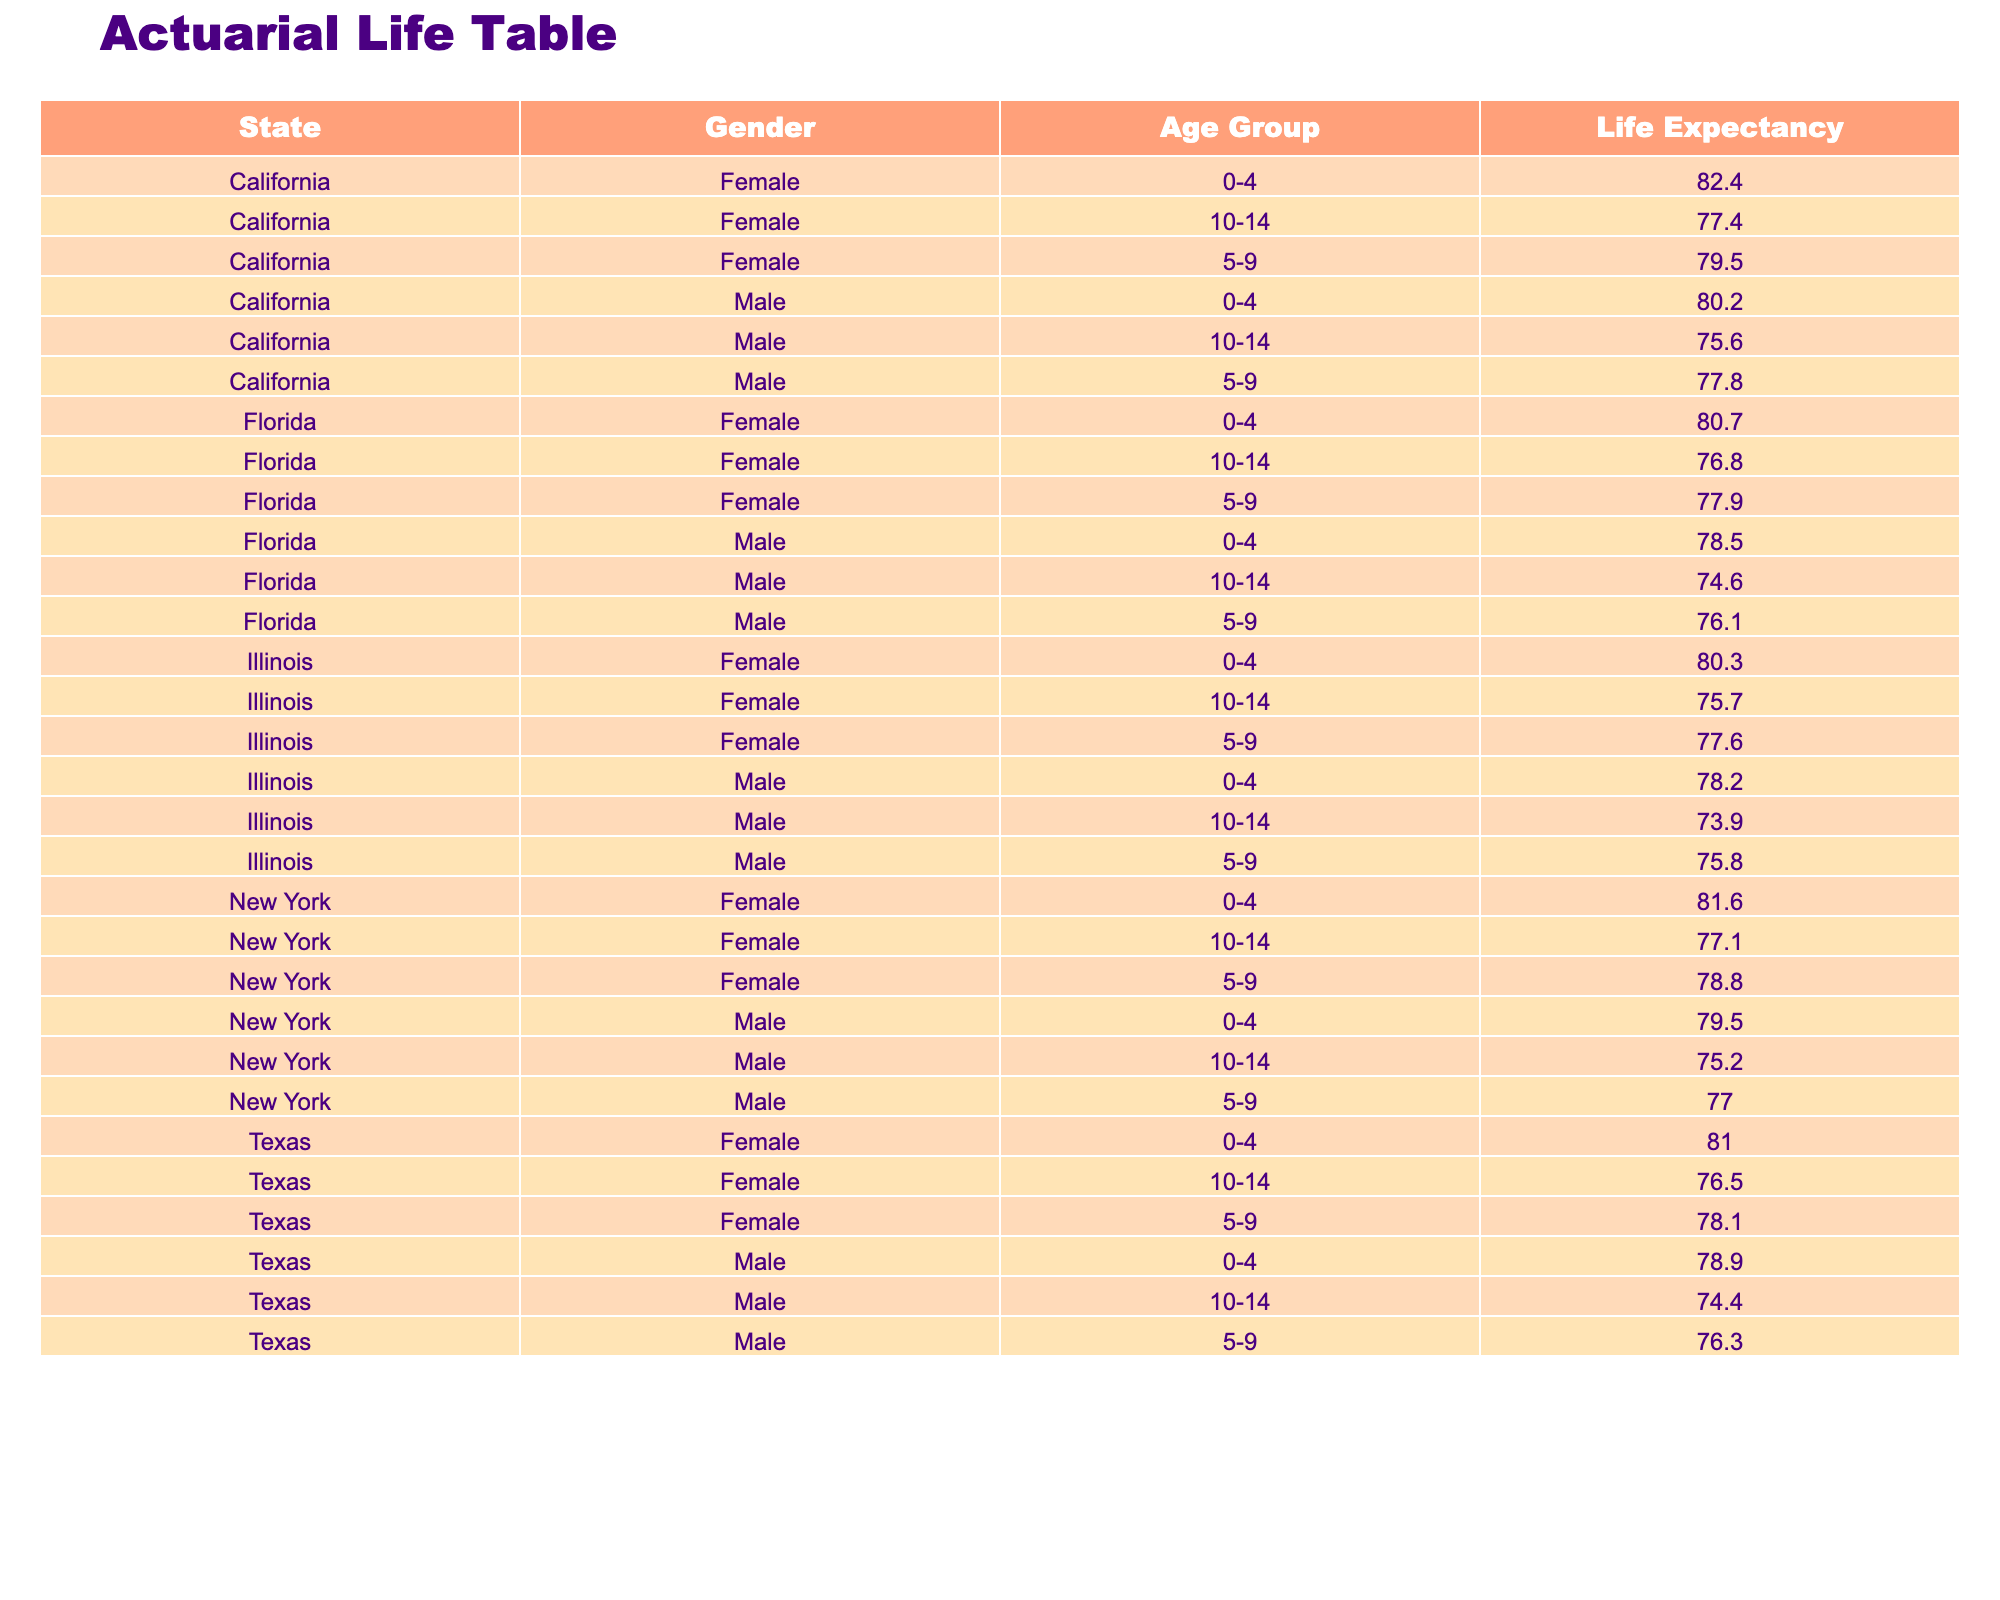What is the life expectancy for males aged 0-4 in California? The table indicates that for California, the life expectancy for males aged 0-4 is 80.2 years, as specified directly in the data.
Answer: 80.2 years What is the life expectancy for females aged 5-9 in Texas? According to the table, for females aged 5-9 in Texas, the life expectancy is 78.1 years. This is a direct reference from the data.
Answer: 78.1 years Which state has the highest life expectancy for females aged 0-4? Looking at the life expectancies for females aged 0-4 from all states, California has a life expectancy of 82.4 years, which is the highest among the listed states.
Answer: California, 82.4 years What is the average life expectancy for males aged 10-14 across all states? To find the average life expectancy for males aged 10-14, we sum the values for each state: (75.6 + 74.4 + 75.2 + 74.6 + 73.9) = 373.7. Then, we divide by the number of states (5), resulting in an average of 373.7/5 = 74.74 years.
Answer: 74.74 years Is the life expectancy for females aged 0-4 in New York higher than that in Florida? In New York, the life expectancy for females aged 0-4 is 81.6 years, while in Florida, it is 80.7 years. Since 81.6 is greater than 80.7, the answer is yes.
Answer: Yes What is the difference in life expectancy for males aged 5-9 between California and New York? The life expectancy for males aged 5-9 in California is 77.8 years, and in New York, it is 77.0 years. The difference is 77.8 - 77.0 = 0.8 years.
Answer: 0.8 years Which gender has a higher life expectancy at age 10-14 in Illinois? The table shows that males have a life expectancy of 73.9 years while females have 75.7 years at age 10-14 in Illinois. Since 75.7 is greater than 73.9, females have a higher life expectancy.
Answer: Females What is the total life expectancy for males aged 0-4 across all four states? The life expectancies are as follows: California (80.2), Texas (78.9), New York (79.5), and Florida (78.5). Summing these gives 80.2 + 78.9 + 79.5 + 78.5 = 317.1 years.
Answer: 317.1 years Is the life expectancy for females aged 10-14 in Texas equal to that in Illinois? In Texas, the life expectancy for females aged 10-14 is 76.5 years, and in Illinois, it is 75.7 years. Since these two values are not equal, the answer is no.
Answer: No 